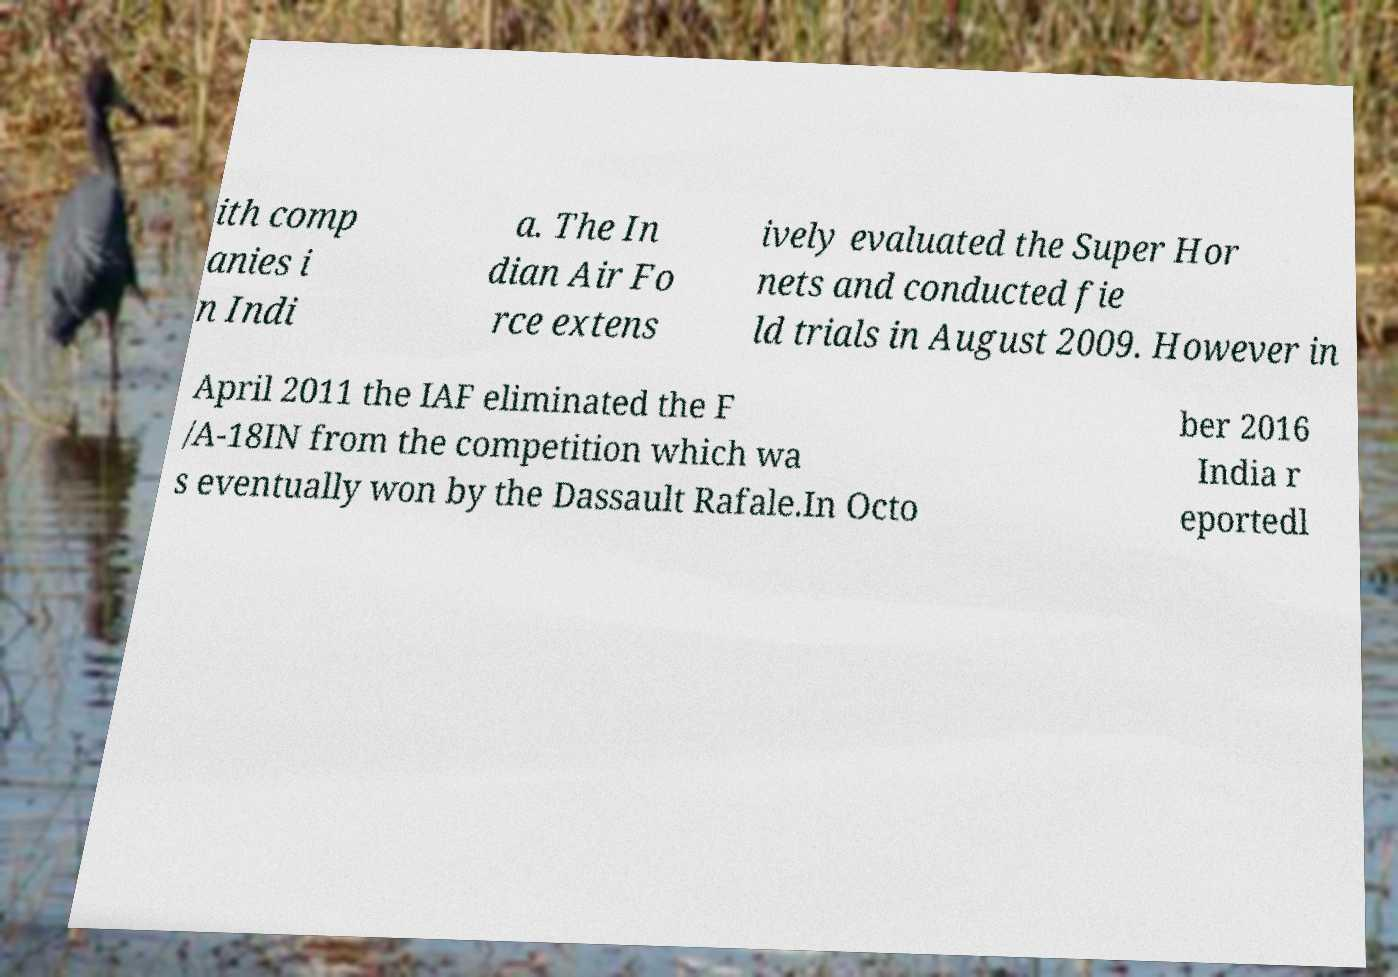Could you extract and type out the text from this image? ith comp anies i n Indi a. The In dian Air Fo rce extens ively evaluated the Super Hor nets and conducted fie ld trials in August 2009. However in April 2011 the IAF eliminated the F /A-18IN from the competition which wa s eventually won by the Dassault Rafale.In Octo ber 2016 India r eportedl 